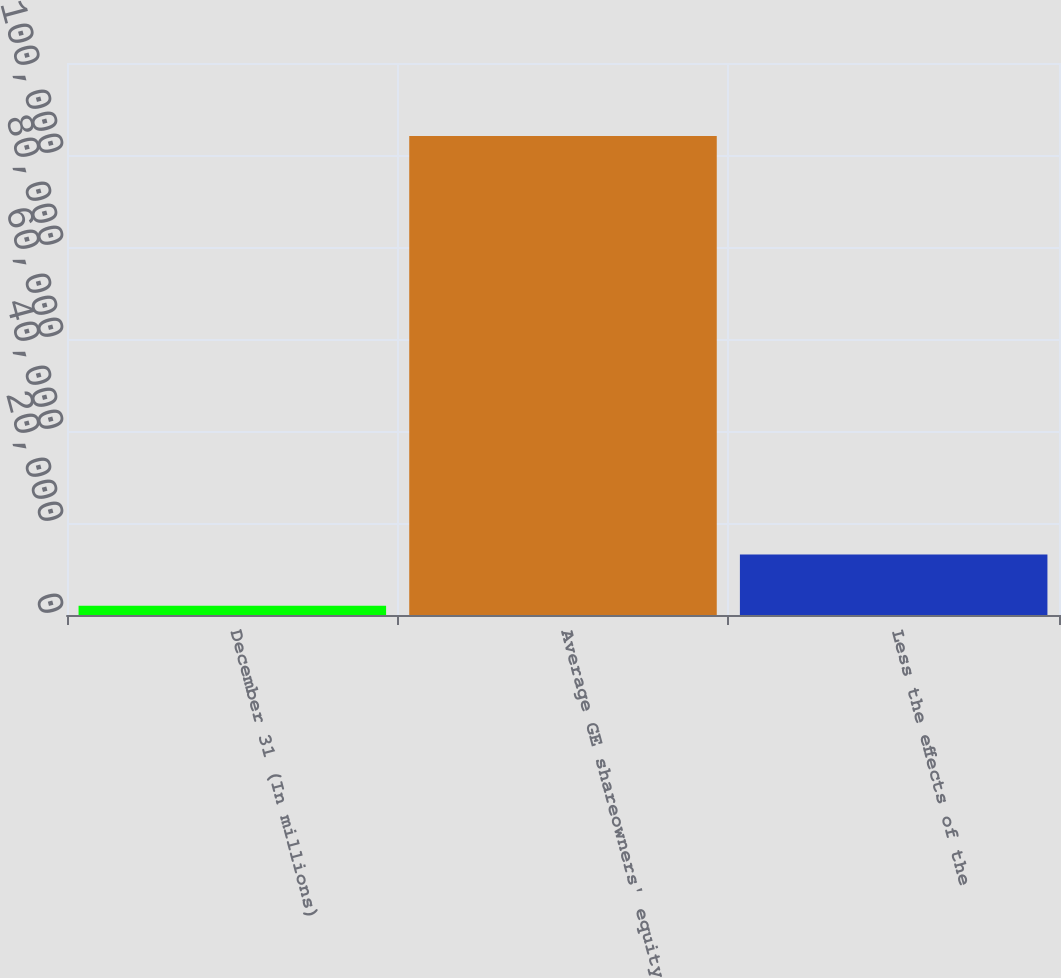Convert chart. <chart><loc_0><loc_0><loc_500><loc_500><bar_chart><fcel>December 31 (In millions)<fcel>Average GE shareowners' equity<fcel>Less the effects of the<nl><fcel>2008<fcel>104139<fcel>13145.9<nl></chart> 